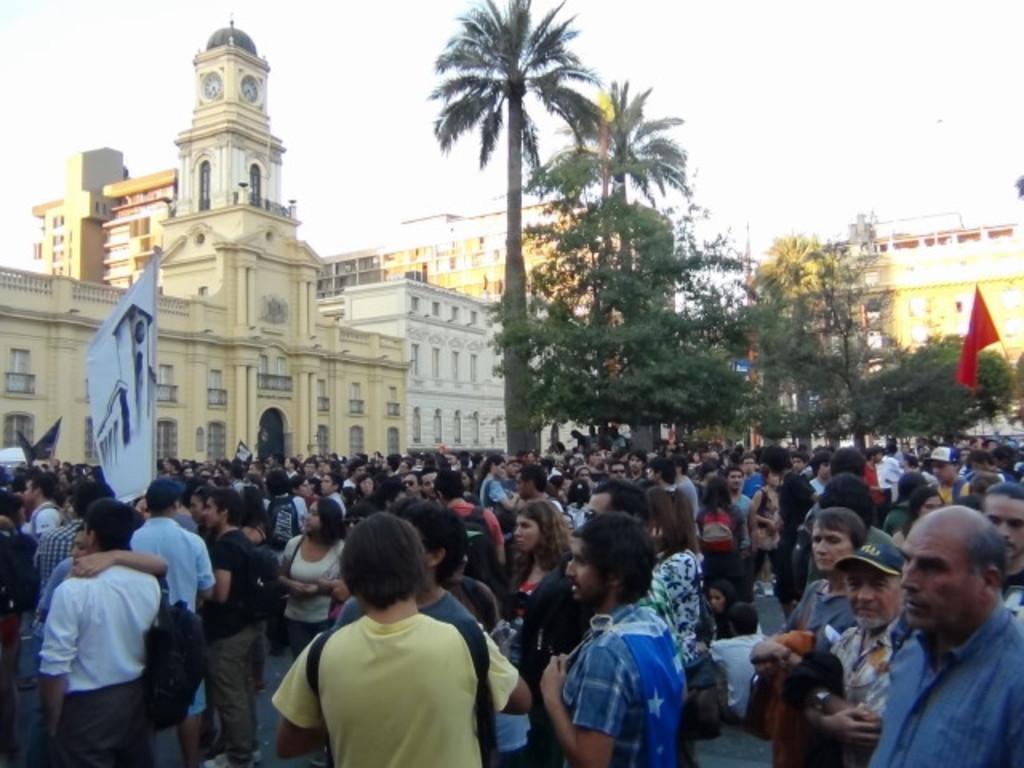How would you summarize this image in a sentence or two? In this picture we can see a group of people on the ground, here we can see a banner, flag and in the background we can see buildings, trees, sky. 